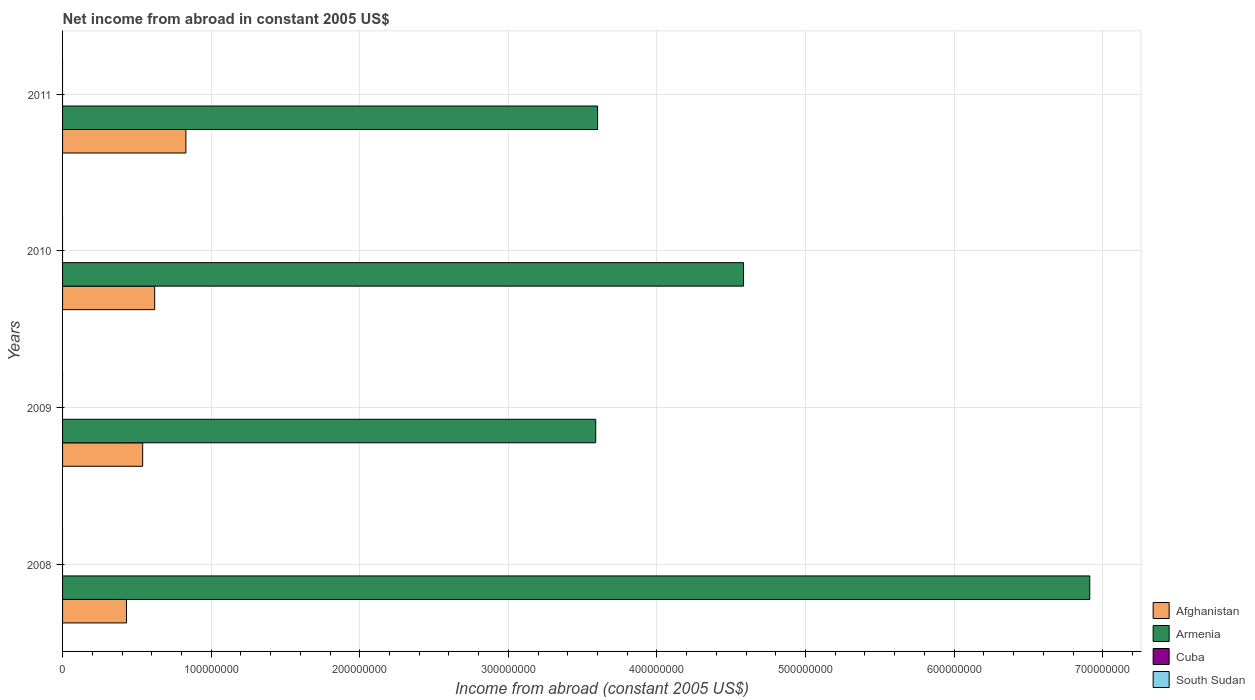How many different coloured bars are there?
Provide a succinct answer. 2. Are the number of bars per tick equal to the number of legend labels?
Give a very brief answer. No. Are the number of bars on each tick of the Y-axis equal?
Offer a very short reply. Yes. What is the net income from abroad in Cuba in 2010?
Provide a succinct answer. 0. Across all years, what is the maximum net income from abroad in Armenia?
Offer a terse response. 6.91e+08. Across all years, what is the minimum net income from abroad in Afghanistan?
Keep it short and to the point. 4.30e+07. What is the total net income from abroad in Armenia in the graph?
Make the answer very short. 1.87e+09. What is the difference between the net income from abroad in Armenia in 2008 and that in 2009?
Give a very brief answer. 3.32e+08. What is the difference between the net income from abroad in South Sudan in 2009 and the net income from abroad in Armenia in 2008?
Offer a terse response. -6.91e+08. What is the average net income from abroad in Afghanistan per year?
Offer a very short reply. 6.05e+07. In how many years, is the net income from abroad in Armenia greater than 440000000 US$?
Offer a very short reply. 2. What is the ratio of the net income from abroad in Afghanistan in 2008 to that in 2009?
Your answer should be very brief. 0.8. What is the difference between the highest and the second highest net income from abroad in Armenia?
Make the answer very short. 2.33e+08. What is the difference between the highest and the lowest net income from abroad in Armenia?
Make the answer very short. 3.32e+08. Is the sum of the net income from abroad in Afghanistan in 2009 and 2010 greater than the maximum net income from abroad in Armenia across all years?
Keep it short and to the point. No. How many bars are there?
Make the answer very short. 8. What is the difference between two consecutive major ticks on the X-axis?
Provide a succinct answer. 1.00e+08. What is the title of the graph?
Your answer should be very brief. Net income from abroad in constant 2005 US$. What is the label or title of the X-axis?
Keep it short and to the point. Income from abroad (constant 2005 US$). What is the Income from abroad (constant 2005 US$) in Afghanistan in 2008?
Ensure brevity in your answer.  4.30e+07. What is the Income from abroad (constant 2005 US$) in Armenia in 2008?
Give a very brief answer. 6.91e+08. What is the Income from abroad (constant 2005 US$) of Cuba in 2008?
Offer a terse response. 0. What is the Income from abroad (constant 2005 US$) of Afghanistan in 2009?
Your answer should be compact. 5.39e+07. What is the Income from abroad (constant 2005 US$) in Armenia in 2009?
Your answer should be very brief. 3.59e+08. What is the Income from abroad (constant 2005 US$) in South Sudan in 2009?
Your answer should be compact. 0. What is the Income from abroad (constant 2005 US$) in Afghanistan in 2010?
Offer a terse response. 6.20e+07. What is the Income from abroad (constant 2005 US$) of Armenia in 2010?
Keep it short and to the point. 4.58e+08. What is the Income from abroad (constant 2005 US$) of Cuba in 2010?
Provide a short and direct response. 0. What is the Income from abroad (constant 2005 US$) in Afghanistan in 2011?
Offer a terse response. 8.30e+07. What is the Income from abroad (constant 2005 US$) in Armenia in 2011?
Give a very brief answer. 3.60e+08. What is the Income from abroad (constant 2005 US$) of Cuba in 2011?
Give a very brief answer. 0. What is the Income from abroad (constant 2005 US$) in South Sudan in 2011?
Your answer should be very brief. 0. Across all years, what is the maximum Income from abroad (constant 2005 US$) of Afghanistan?
Your answer should be compact. 8.30e+07. Across all years, what is the maximum Income from abroad (constant 2005 US$) in Armenia?
Offer a terse response. 6.91e+08. Across all years, what is the minimum Income from abroad (constant 2005 US$) in Afghanistan?
Your response must be concise. 4.30e+07. Across all years, what is the minimum Income from abroad (constant 2005 US$) in Armenia?
Your answer should be very brief. 3.59e+08. What is the total Income from abroad (constant 2005 US$) in Afghanistan in the graph?
Provide a succinct answer. 2.42e+08. What is the total Income from abroad (constant 2005 US$) in Armenia in the graph?
Offer a terse response. 1.87e+09. What is the total Income from abroad (constant 2005 US$) in South Sudan in the graph?
Keep it short and to the point. 0. What is the difference between the Income from abroad (constant 2005 US$) in Afghanistan in 2008 and that in 2009?
Give a very brief answer. -1.09e+07. What is the difference between the Income from abroad (constant 2005 US$) in Armenia in 2008 and that in 2009?
Your answer should be very brief. 3.32e+08. What is the difference between the Income from abroad (constant 2005 US$) in Afghanistan in 2008 and that in 2010?
Your answer should be very brief. -1.90e+07. What is the difference between the Income from abroad (constant 2005 US$) in Armenia in 2008 and that in 2010?
Offer a very short reply. 2.33e+08. What is the difference between the Income from abroad (constant 2005 US$) of Afghanistan in 2008 and that in 2011?
Your answer should be compact. -4.00e+07. What is the difference between the Income from abroad (constant 2005 US$) in Armenia in 2008 and that in 2011?
Ensure brevity in your answer.  3.31e+08. What is the difference between the Income from abroad (constant 2005 US$) in Afghanistan in 2009 and that in 2010?
Your response must be concise. -8.09e+06. What is the difference between the Income from abroad (constant 2005 US$) in Armenia in 2009 and that in 2010?
Offer a very short reply. -9.95e+07. What is the difference between the Income from abroad (constant 2005 US$) in Afghanistan in 2009 and that in 2011?
Keep it short and to the point. -2.91e+07. What is the difference between the Income from abroad (constant 2005 US$) of Armenia in 2009 and that in 2011?
Give a very brief answer. -1.29e+06. What is the difference between the Income from abroad (constant 2005 US$) of Afghanistan in 2010 and that in 2011?
Keep it short and to the point. -2.10e+07. What is the difference between the Income from abroad (constant 2005 US$) of Armenia in 2010 and that in 2011?
Offer a very short reply. 9.82e+07. What is the difference between the Income from abroad (constant 2005 US$) of Afghanistan in 2008 and the Income from abroad (constant 2005 US$) of Armenia in 2009?
Provide a succinct answer. -3.16e+08. What is the difference between the Income from abroad (constant 2005 US$) of Afghanistan in 2008 and the Income from abroad (constant 2005 US$) of Armenia in 2010?
Offer a very short reply. -4.15e+08. What is the difference between the Income from abroad (constant 2005 US$) in Afghanistan in 2008 and the Income from abroad (constant 2005 US$) in Armenia in 2011?
Your answer should be compact. -3.17e+08. What is the difference between the Income from abroad (constant 2005 US$) in Afghanistan in 2009 and the Income from abroad (constant 2005 US$) in Armenia in 2010?
Give a very brief answer. -4.04e+08. What is the difference between the Income from abroad (constant 2005 US$) in Afghanistan in 2009 and the Income from abroad (constant 2005 US$) in Armenia in 2011?
Ensure brevity in your answer.  -3.06e+08. What is the difference between the Income from abroad (constant 2005 US$) of Afghanistan in 2010 and the Income from abroad (constant 2005 US$) of Armenia in 2011?
Your answer should be compact. -2.98e+08. What is the average Income from abroad (constant 2005 US$) of Afghanistan per year?
Offer a very short reply. 6.05e+07. What is the average Income from abroad (constant 2005 US$) in Armenia per year?
Your response must be concise. 4.67e+08. What is the average Income from abroad (constant 2005 US$) in Cuba per year?
Your response must be concise. 0. In the year 2008, what is the difference between the Income from abroad (constant 2005 US$) in Afghanistan and Income from abroad (constant 2005 US$) in Armenia?
Offer a very short reply. -6.48e+08. In the year 2009, what is the difference between the Income from abroad (constant 2005 US$) of Afghanistan and Income from abroad (constant 2005 US$) of Armenia?
Offer a very short reply. -3.05e+08. In the year 2010, what is the difference between the Income from abroad (constant 2005 US$) of Afghanistan and Income from abroad (constant 2005 US$) of Armenia?
Make the answer very short. -3.96e+08. In the year 2011, what is the difference between the Income from abroad (constant 2005 US$) of Afghanistan and Income from abroad (constant 2005 US$) of Armenia?
Provide a succinct answer. -2.77e+08. What is the ratio of the Income from abroad (constant 2005 US$) of Afghanistan in 2008 to that in 2009?
Give a very brief answer. 0.8. What is the ratio of the Income from abroad (constant 2005 US$) in Armenia in 2008 to that in 2009?
Your answer should be compact. 1.93. What is the ratio of the Income from abroad (constant 2005 US$) in Afghanistan in 2008 to that in 2010?
Your answer should be compact. 0.69. What is the ratio of the Income from abroad (constant 2005 US$) in Armenia in 2008 to that in 2010?
Keep it short and to the point. 1.51. What is the ratio of the Income from abroad (constant 2005 US$) in Afghanistan in 2008 to that in 2011?
Your answer should be compact. 0.52. What is the ratio of the Income from abroad (constant 2005 US$) of Armenia in 2008 to that in 2011?
Ensure brevity in your answer.  1.92. What is the ratio of the Income from abroad (constant 2005 US$) in Afghanistan in 2009 to that in 2010?
Give a very brief answer. 0.87. What is the ratio of the Income from abroad (constant 2005 US$) in Armenia in 2009 to that in 2010?
Your response must be concise. 0.78. What is the ratio of the Income from abroad (constant 2005 US$) of Afghanistan in 2009 to that in 2011?
Your response must be concise. 0.65. What is the ratio of the Income from abroad (constant 2005 US$) in Armenia in 2009 to that in 2011?
Ensure brevity in your answer.  1. What is the ratio of the Income from abroad (constant 2005 US$) in Afghanistan in 2010 to that in 2011?
Offer a very short reply. 0.75. What is the ratio of the Income from abroad (constant 2005 US$) in Armenia in 2010 to that in 2011?
Ensure brevity in your answer.  1.27. What is the difference between the highest and the second highest Income from abroad (constant 2005 US$) of Afghanistan?
Offer a terse response. 2.10e+07. What is the difference between the highest and the second highest Income from abroad (constant 2005 US$) in Armenia?
Offer a very short reply. 2.33e+08. What is the difference between the highest and the lowest Income from abroad (constant 2005 US$) of Afghanistan?
Offer a very short reply. 4.00e+07. What is the difference between the highest and the lowest Income from abroad (constant 2005 US$) of Armenia?
Provide a succinct answer. 3.32e+08. 